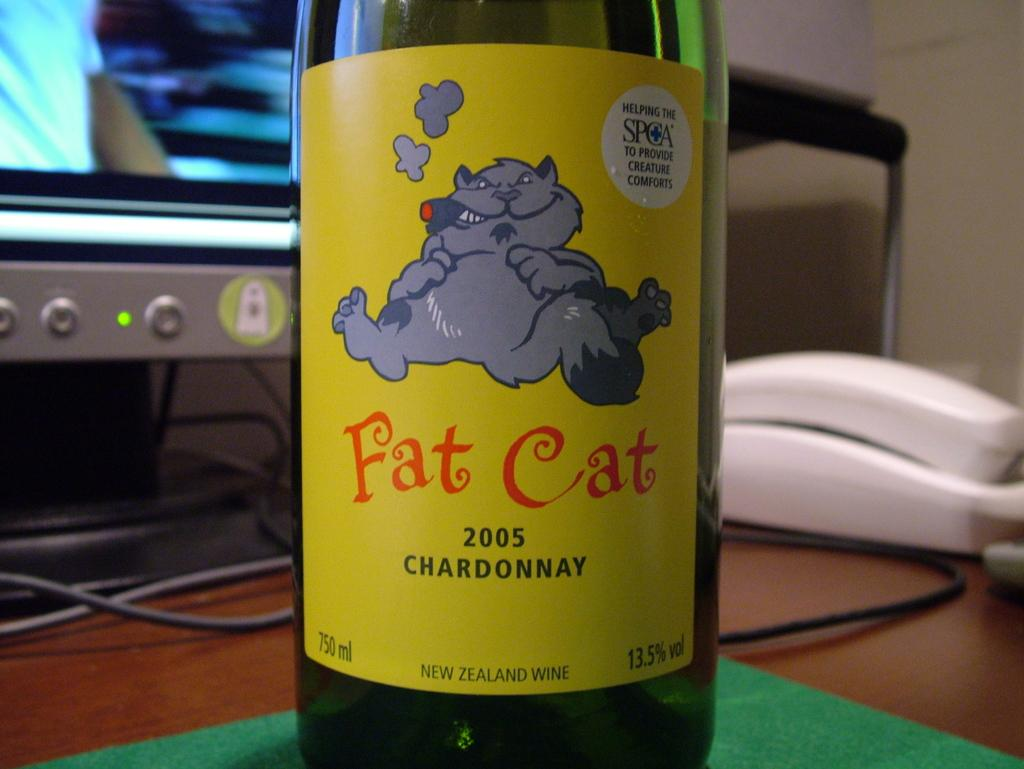Provide a one-sentence caption for the provided image. A bottle of Fat cat Chardonnay is sitting in front of a computer monitor. 